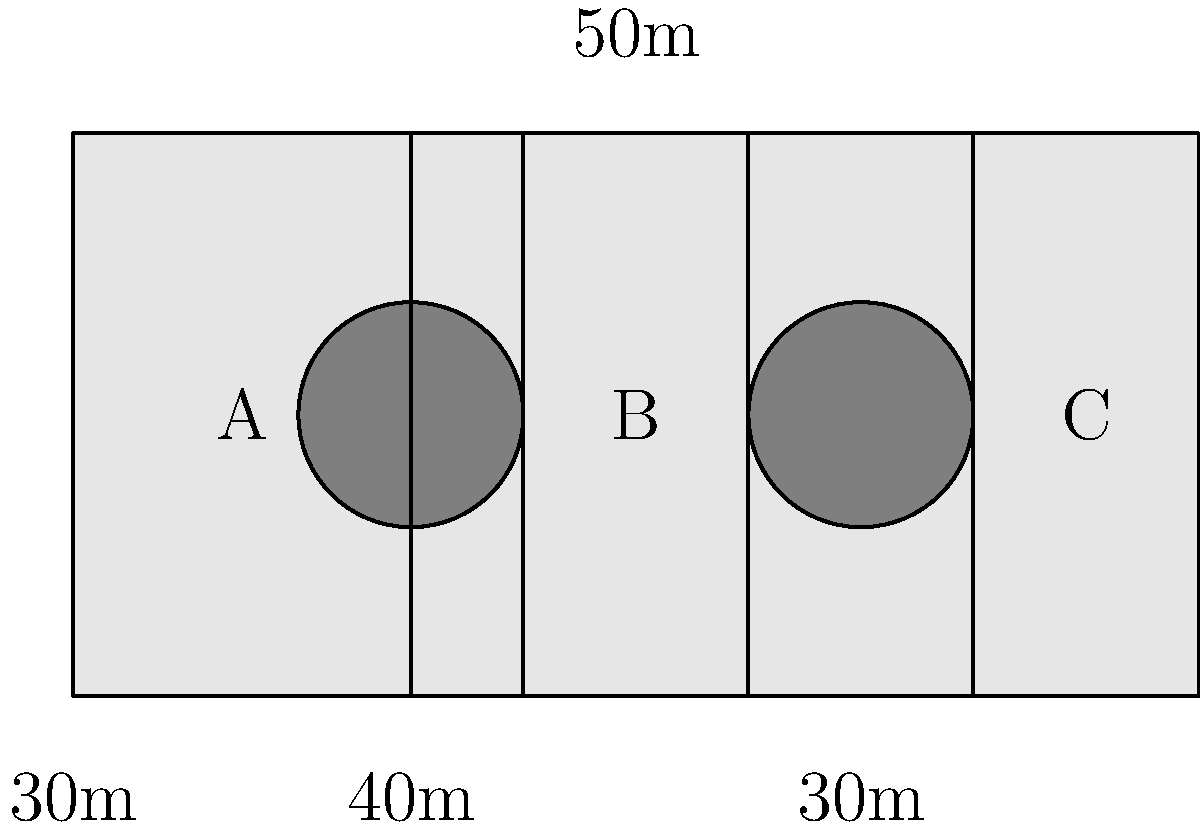As a ship captain implementing sustainable practices, you're tasked with optimizing the placement of solar panels on your ship's deck. The deck measures 100m in length and 50m in width, with two circular obstacles (each with a 10m radius) located as shown in the diagram. Three potential areas (A, B, and C) have been identified for solar panel installation. Which area provides the largest surface for solar panels, and what is its size in square meters? To solve this problem, we need to calculate the area of each potential solar panel placement and compare them:

1. Area A:
   Length = 30m, Width = 50m
   $A_A = 30 \times 50 = 1500$ m²

2. Area B:
   Length = 20m, Width = 50m
   $A_B = 20 \times 50 = 1000$ m²

3. Area C:
   Length = 20m, Width = 50m
   $A_C = 20 \times 50 = 1000$ m²

Comparing the areas:
$A_A > A_B = A_C$

Therefore, Area A provides the largest surface for solar panels with an area of 1500 m².
Answer: Area A, 1500 m² 